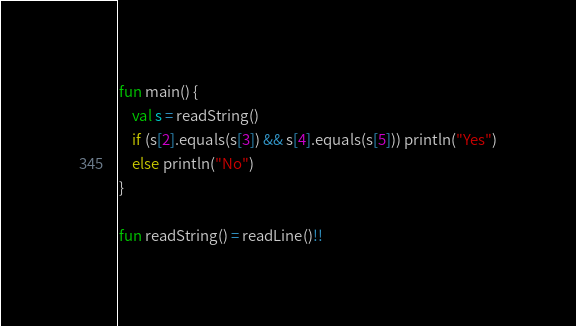Convert code to text. <code><loc_0><loc_0><loc_500><loc_500><_Kotlin_>fun main() {
    val s = readString()
    if (s[2].equals(s[3]) && s[4].equals(s[5])) println("Yes")
    else println("No")
}

fun readString() = readLine()!!</code> 